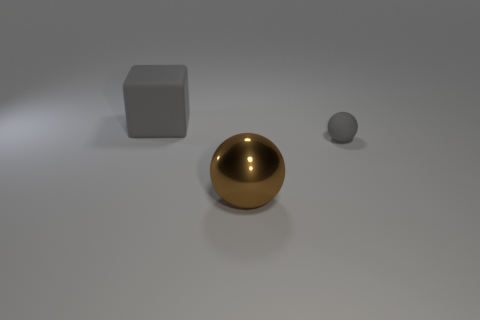Add 2 purple metallic cylinders. How many objects exist? 5 Subtract all balls. How many objects are left? 1 Subtract all big rubber cylinders. Subtract all large matte blocks. How many objects are left? 2 Add 1 balls. How many balls are left? 3 Add 3 blue balls. How many blue balls exist? 3 Subtract 0 blue cubes. How many objects are left? 3 